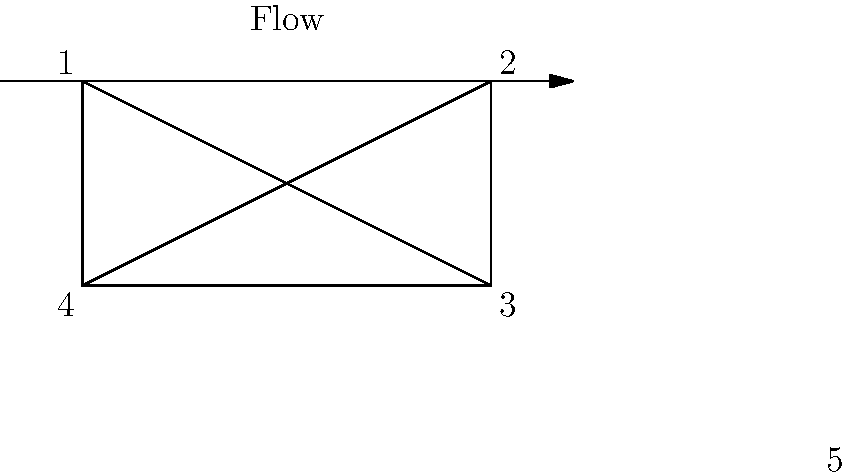In the quality control checklist flowchart above, which pair of angles are congruent and ensure the symmetry of the product inspection process? To identify the congruent angles in this quality control checklist flowchart, we need to analyze the geometric properties of the diagram:

1. The flowchart is in the shape of a rectangle with diagonals.
2. In a rectangle, opposite angles are congruent.
3. When diagonals intersect in a rectangle, they form congruent angles.

Let's examine the angles:
- Angle 1 and Angle 3 are opposite angles in the rectangle.
- Angle 2 and Angle 4 are also opposite angles in the rectangle.
- Angles formed at point 5 (where the diagonals intersect) are all congruent.

The question asks for a pair of congruent angles that ensure symmetry in the product inspection process. The most relevant pair for this purpose would be the angles formed by the diagonals at their intersection point (labeled as 5).

These angles represent the central point of the inspection process where different stages converge, ensuring a balanced and symmetrical approach to quality control.
Answer: The angles at point 5 